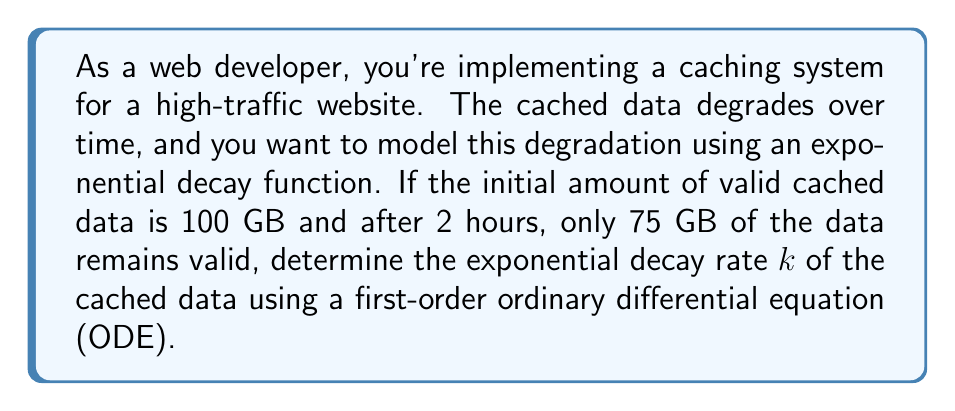Show me your answer to this math problem. Let's approach this step-by-step:

1) The general form of an exponential decay function is:

   $$A(t) = A_0e^{-kt}$$

   where $A(t)$ is the amount at time $t$, $A_0$ is the initial amount, $k$ is the decay rate, and $t$ is time.

2) We can express this as a first-order ODE:

   $$\frac{dA}{dt} = -kA$$

3) Given information:
   - Initial amount $A_0 = 100$ GB
   - After 2 hours $(t = 2)$, $A(2) = 75$ GB

4) Substituting into the exponential decay function:

   $$75 = 100e^{-k(2)}$$

5) Dividing both sides by 100:

   $$0.75 = e^{-2k}$$

6) Taking the natural logarithm of both sides:

   $$\ln(0.75) = -2k$$

7) Solving for $k$:

   $$k = -\frac{\ln(0.75)}{2}$$

8) Calculate the value:

   $$k = -\frac{\ln(0.75)}{2} \approx 0.1438$$

Thus, the exponential decay rate is approximately 0.1438 per hour.
Answer: $k \approx 0.1438$ per hour 